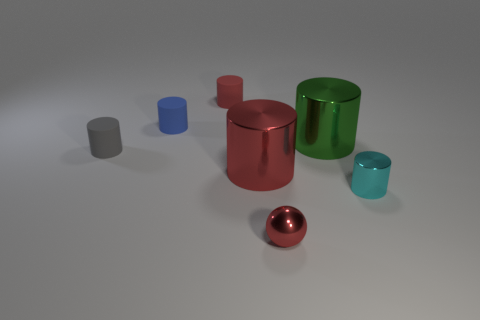What number of objects are either big objects in front of the gray rubber cylinder or blue metal cylinders?
Your answer should be compact. 1. The tiny metallic object that is to the left of the large metal thing that is on the right side of the small red ball is what shape?
Keep it short and to the point. Sphere. Do the red metallic sphere and the red cylinder that is in front of the small red cylinder have the same size?
Your answer should be very brief. No. There is a red thing that is in front of the cyan shiny thing; what is its material?
Provide a succinct answer. Metal. What number of small objects are in front of the tiny shiny cylinder and left of the red rubber object?
Your response must be concise. 0. There is a cyan thing that is the same size as the gray rubber thing; what material is it?
Provide a short and direct response. Metal. There is a matte cylinder that is behind the small blue rubber object; does it have the same size as the object left of the blue rubber cylinder?
Your response must be concise. Yes. Are there any gray rubber objects to the left of the large red metal cylinder?
Make the answer very short. Yes. There is a big object that is left of the object in front of the cyan shiny object; what is its color?
Your answer should be compact. Red. Are there fewer large green shiny objects than yellow cylinders?
Give a very brief answer. No. 